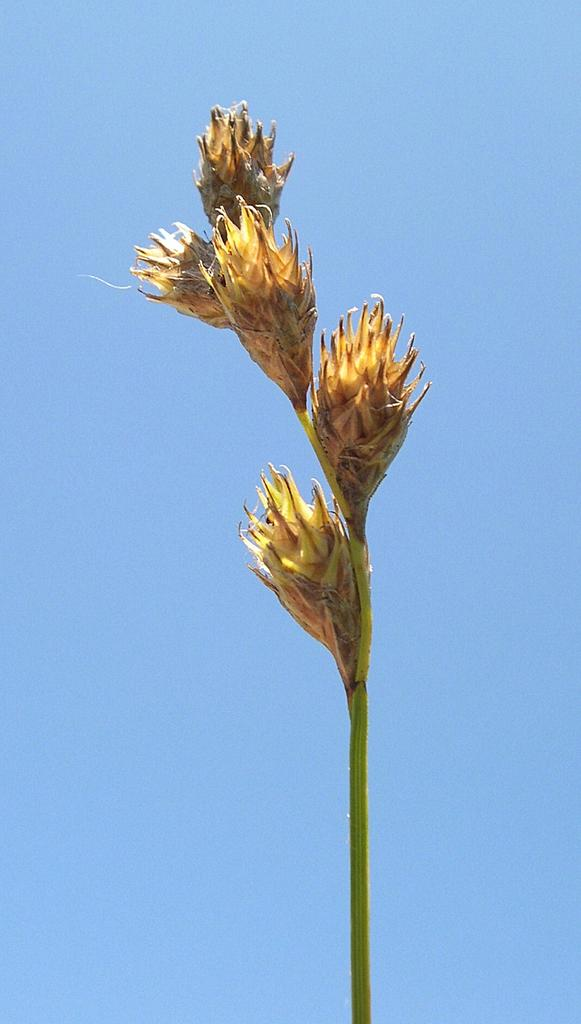What type of living organisms can be seen in the image? There are flowers in the image. What can be seen in the background of the image? The sky is visible in the background of the image. What type of stove is used to cook the flowers in the image? There is no stove present in the image, and flowers are not cooked. 